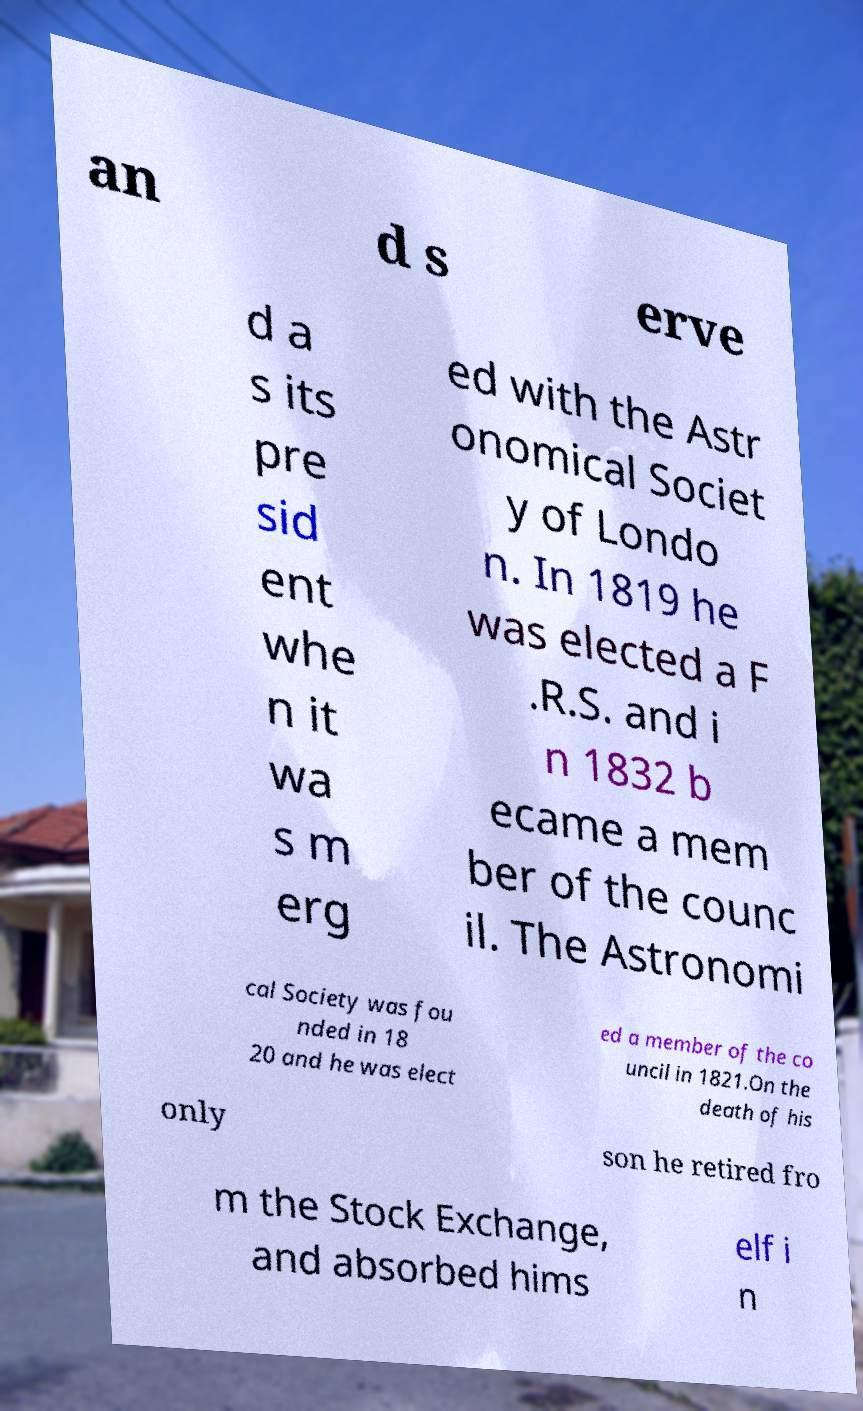For documentation purposes, I need the text within this image transcribed. Could you provide that? an d s erve d a s its pre sid ent whe n it wa s m erg ed with the Astr onomical Societ y of Londo n. In 1819 he was elected a F .R.S. and i n 1832 b ecame a mem ber of the counc il. The Astronomi cal Society was fou nded in 18 20 and he was elect ed a member of the co uncil in 1821.On the death of his only son he retired fro m the Stock Exchange, and absorbed hims elf i n 